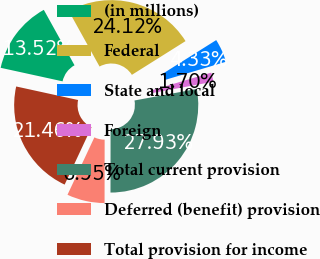<chart> <loc_0><loc_0><loc_500><loc_500><pie_chart><fcel>(in millions)<fcel>Federal<fcel>State and local<fcel>Foreign<fcel>Total current provision<fcel>Deferred (benefit) provision<fcel>Total provision for income<nl><fcel>13.52%<fcel>24.12%<fcel>4.33%<fcel>1.7%<fcel>27.93%<fcel>6.95%<fcel>21.46%<nl></chart> 